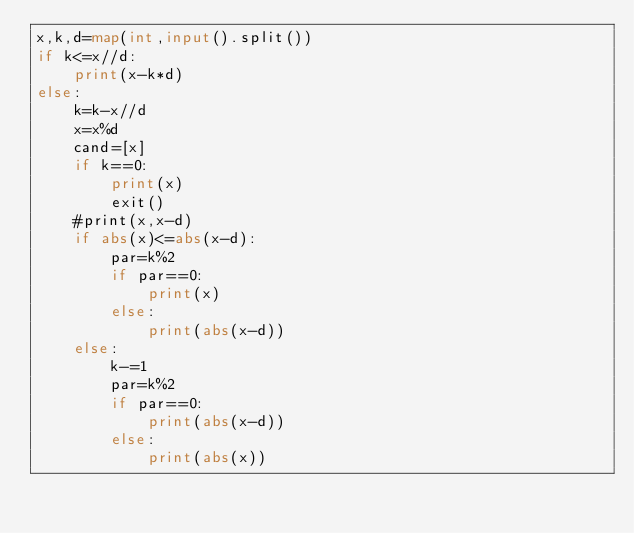Convert code to text. <code><loc_0><loc_0><loc_500><loc_500><_Python_>x,k,d=map(int,input().split())
if k<=x//d:
    print(x-k*d)
else:
    k=k-x//d
    x=x%d
    cand=[x]
    if k==0:
        print(x)
        exit()
    #print(x,x-d)
    if abs(x)<=abs(x-d):
        par=k%2
        if par==0:
            print(x)
        else:
            print(abs(x-d))
    else:
        k-=1
        par=k%2
        if par==0:
            print(abs(x-d))
        else:
            print(abs(x))</code> 